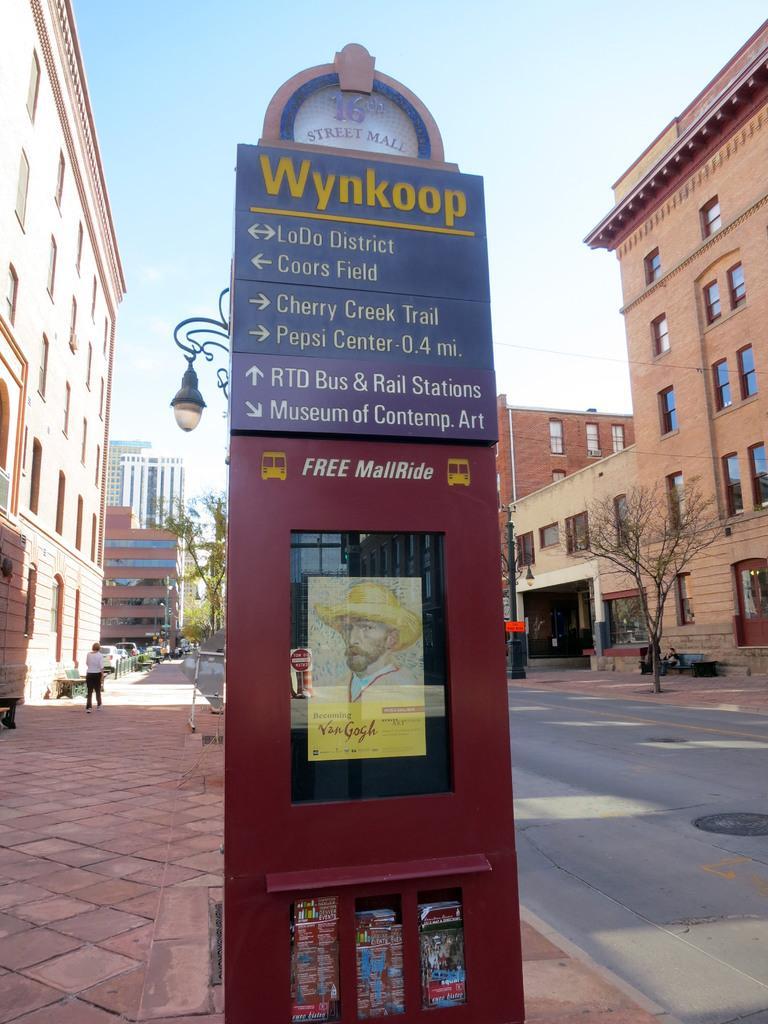How would you summarize this image in a sentence or two? In the middle it is a board, there are buildings on either side of this road, in the right side it is a tree. 